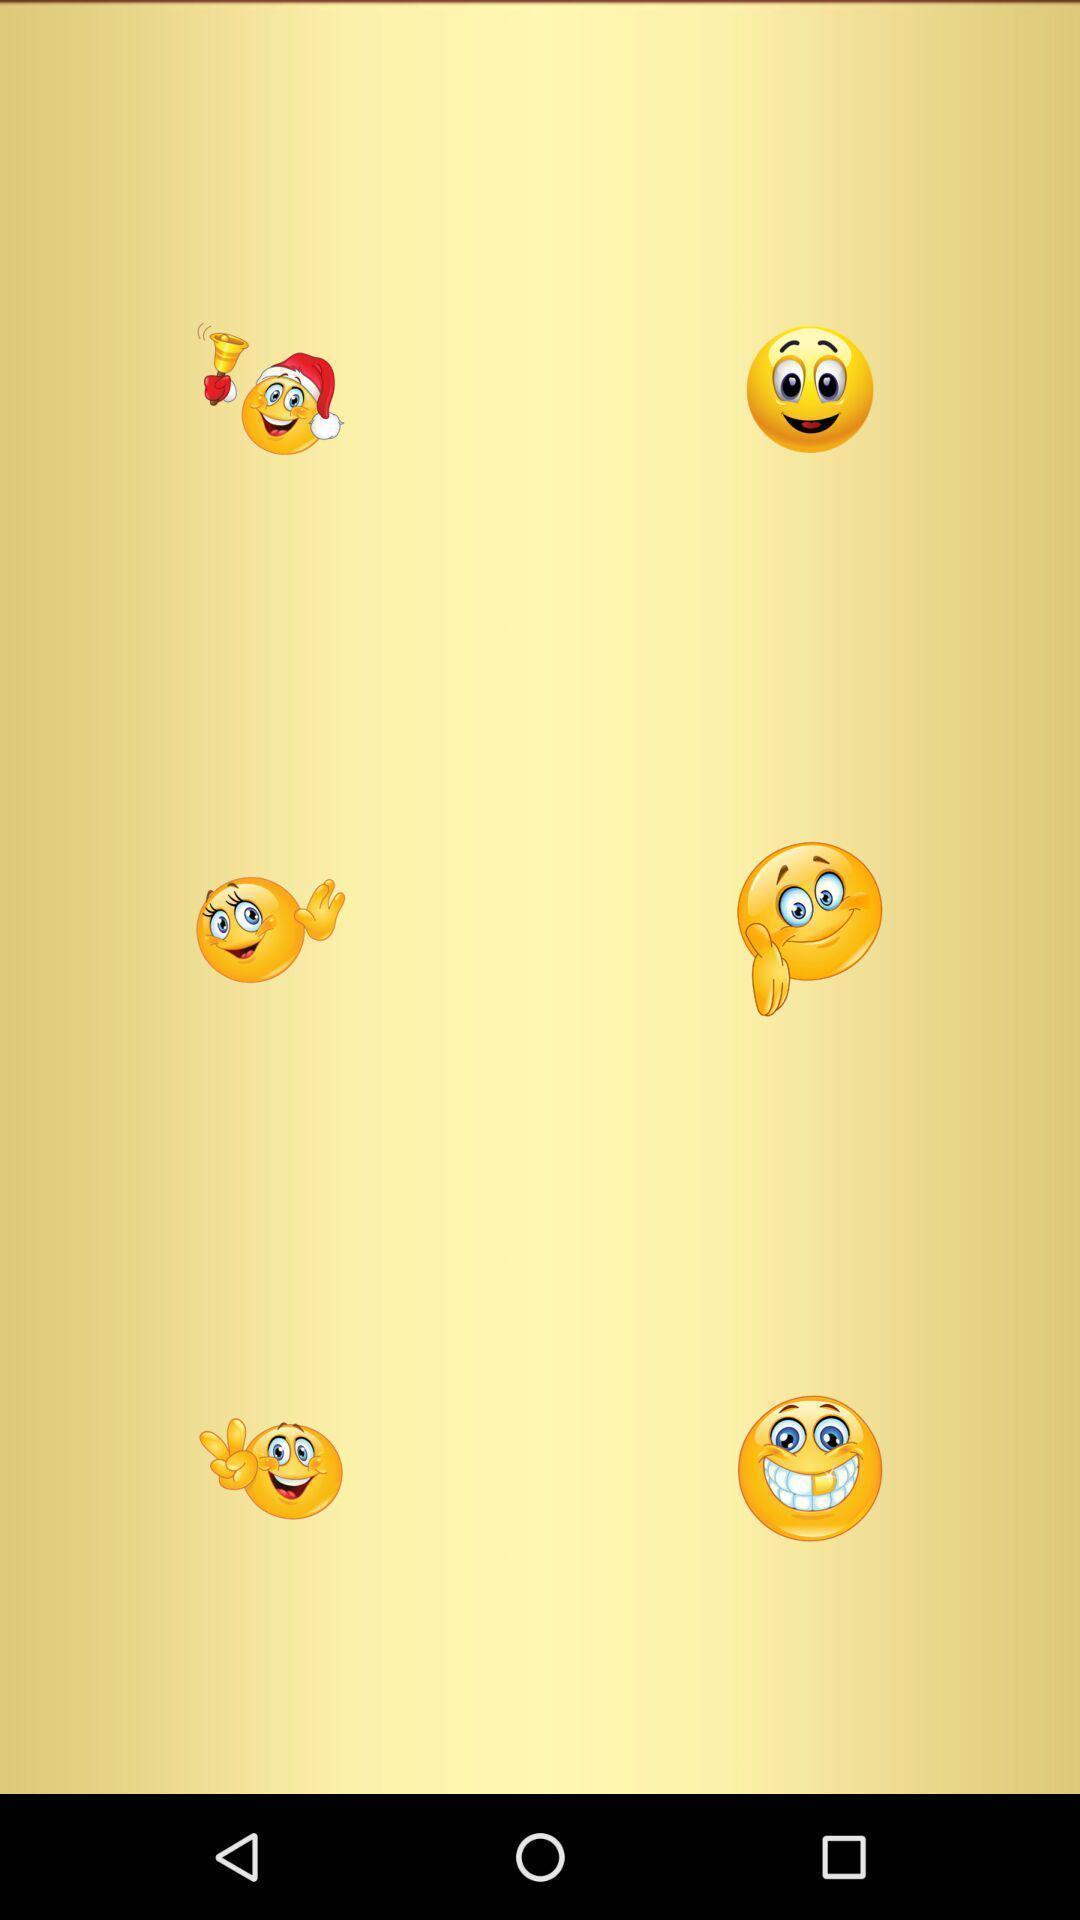Give me a narrative description of this picture. Screen displaying the various emojis. 